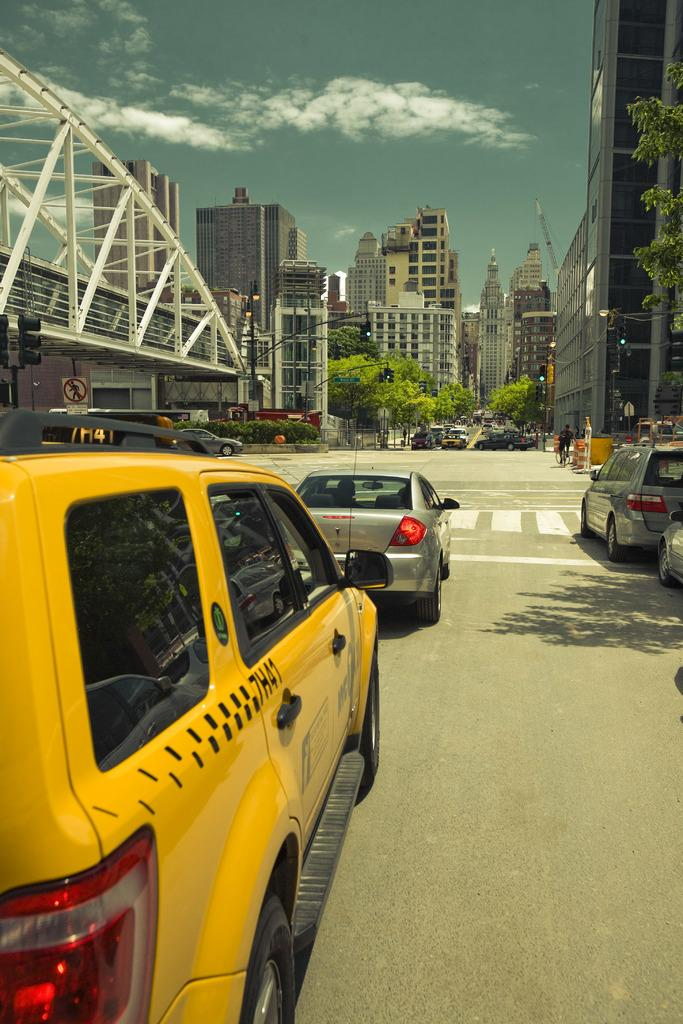What can be seen on the road in the image? There are cars on the road in the image. What type of vegetation is visible in the background? There are trees in the background of the image. What structures are located in front of the trees in the background? There are buildings in front of the trees in the background. What is visible above the buildings and trees? The sky is visible in the image. What can be observed in the sky? Clouds are present in the sky. Can you tell me the story behind the jar in the image? There is no jar present in the image, so there is no story to tell about it. What type of umbrella is being used by the trees in the image? There are no umbrellas present in the image, and trees do not use umbrellas. 